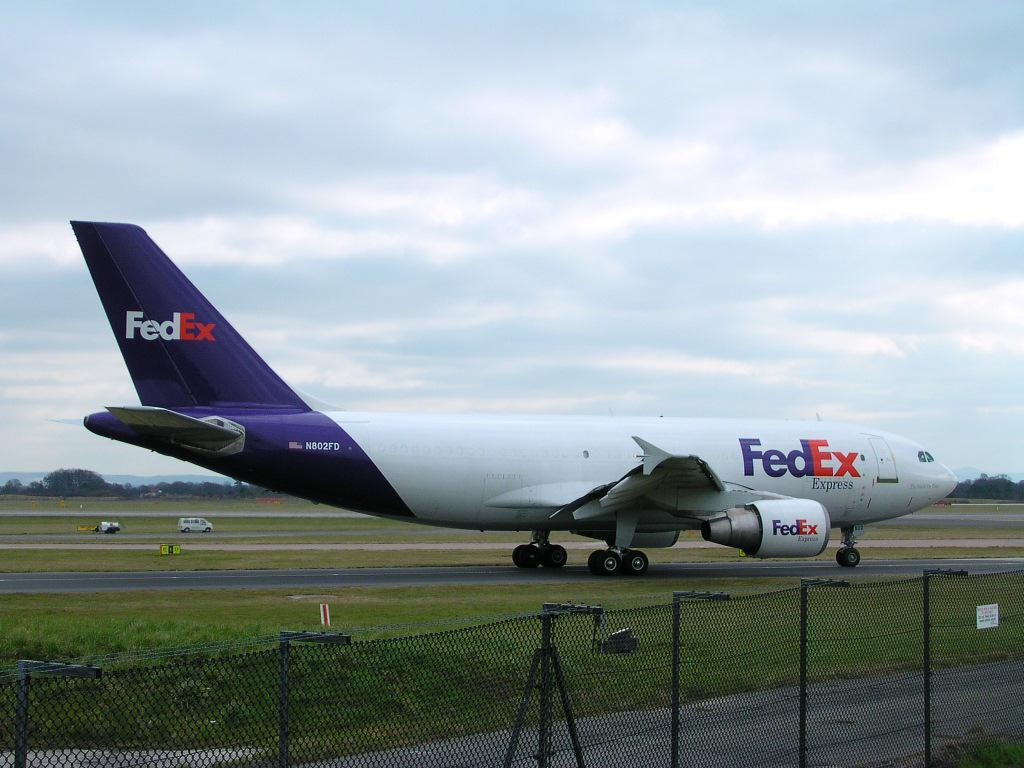<image>
Describe the image concisely. a FedEX Express jet on the runway waiting to take off 